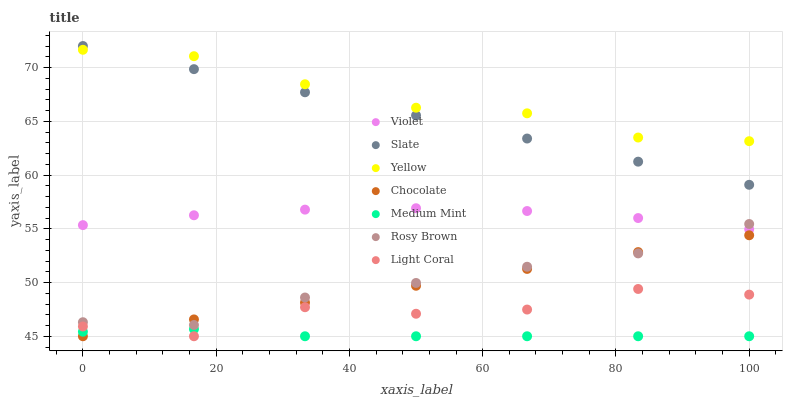Does Medium Mint have the minimum area under the curve?
Answer yes or no. Yes. Does Yellow have the maximum area under the curve?
Answer yes or no. Yes. Does Slate have the minimum area under the curve?
Answer yes or no. No. Does Slate have the maximum area under the curve?
Answer yes or no. No. Is Slate the smoothest?
Answer yes or no. Yes. Is Light Coral the roughest?
Answer yes or no. Yes. Is Rosy Brown the smoothest?
Answer yes or no. No. Is Rosy Brown the roughest?
Answer yes or no. No. Does Medium Mint have the lowest value?
Answer yes or no. Yes. Does Slate have the lowest value?
Answer yes or no. No. Does Slate have the highest value?
Answer yes or no. Yes. Does Rosy Brown have the highest value?
Answer yes or no. No. Is Light Coral less than Rosy Brown?
Answer yes or no. Yes. Is Yellow greater than Chocolate?
Answer yes or no. Yes. Does Medium Mint intersect Chocolate?
Answer yes or no. Yes. Is Medium Mint less than Chocolate?
Answer yes or no. No. Is Medium Mint greater than Chocolate?
Answer yes or no. No. Does Light Coral intersect Rosy Brown?
Answer yes or no. No. 